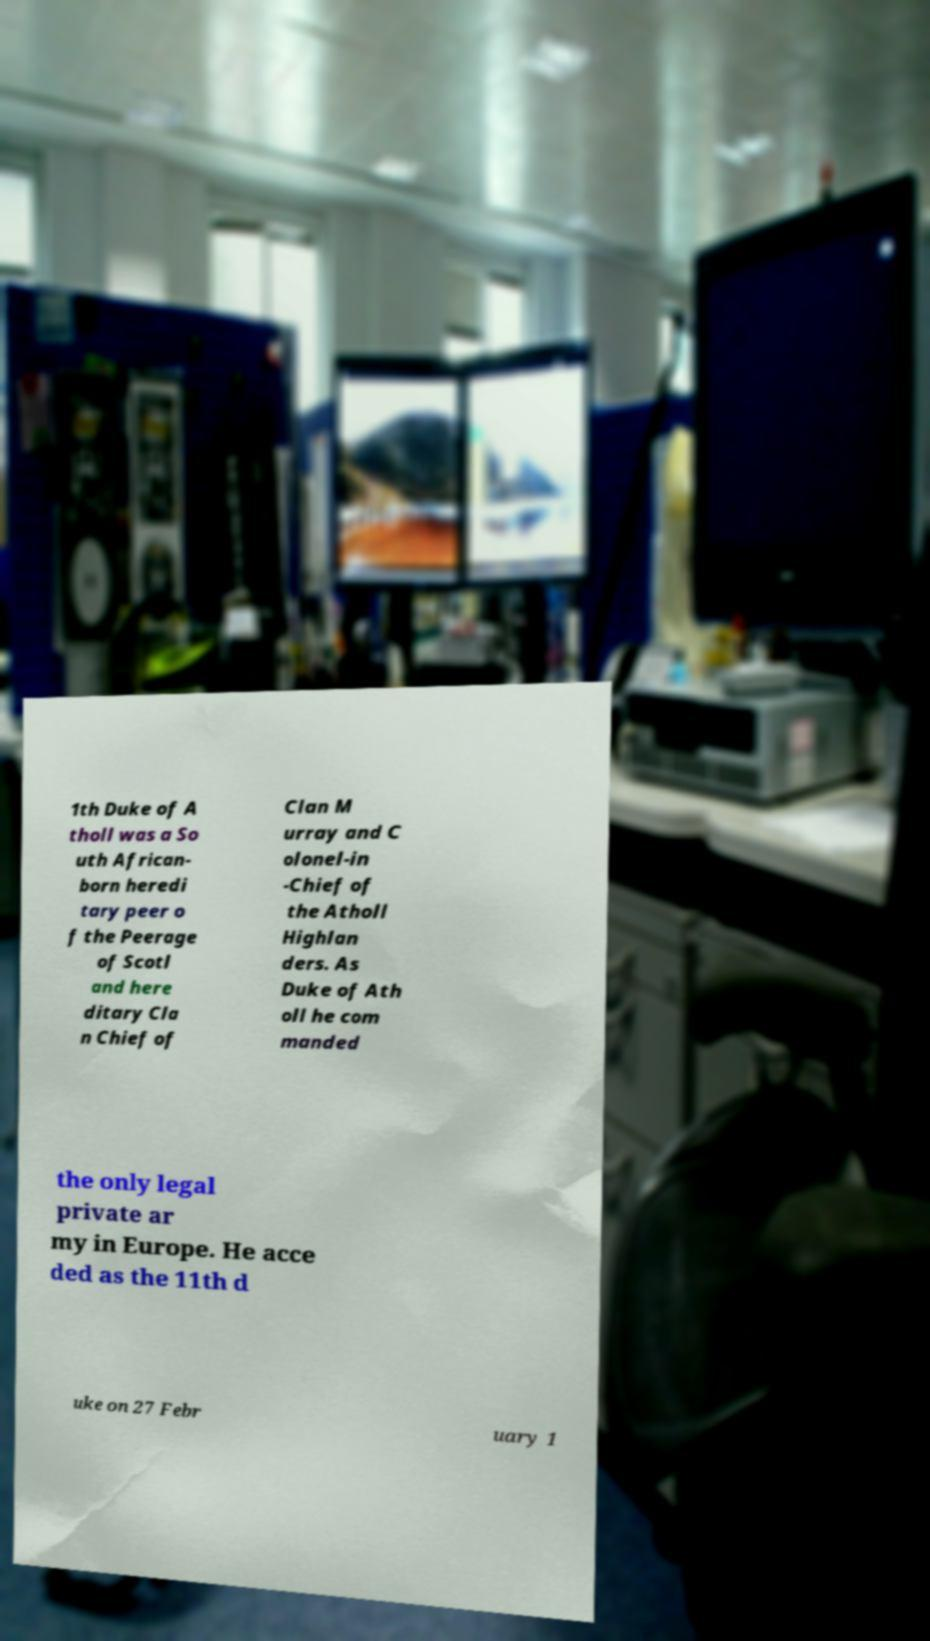I need the written content from this picture converted into text. Can you do that? 1th Duke of A tholl was a So uth African- born heredi tary peer o f the Peerage of Scotl and here ditary Cla n Chief of Clan M urray and C olonel-in -Chief of the Atholl Highlan ders. As Duke of Ath oll he com manded the only legal private ar my in Europe. He acce ded as the 11th d uke on 27 Febr uary 1 